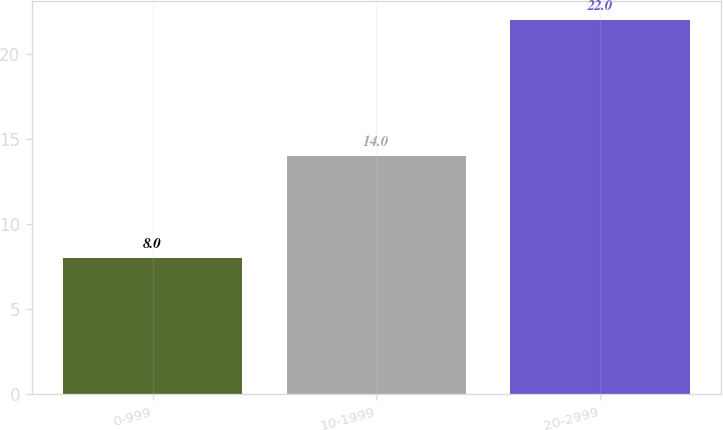Convert chart. <chart><loc_0><loc_0><loc_500><loc_500><bar_chart><fcel>0-999<fcel>10-1999<fcel>20-2999<nl><fcel>8<fcel>14<fcel>22<nl></chart> 